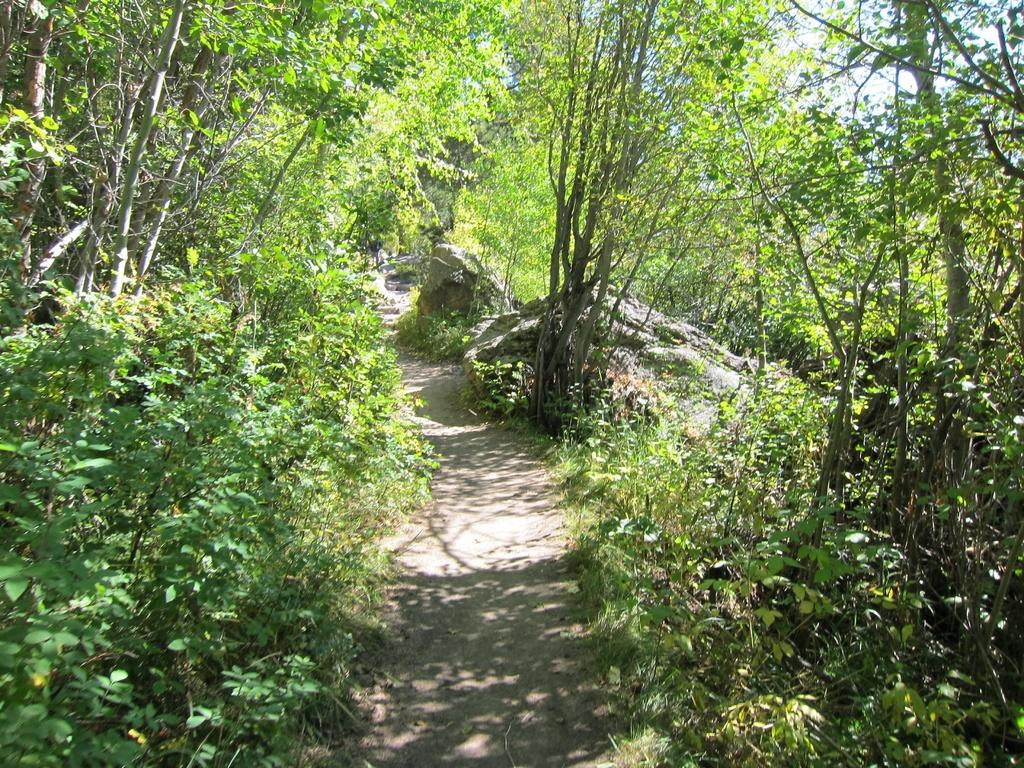What type of environment might the image be taken in? The image might be taken in a forest, as there are trees visible on both sides. Can you describe the left side of the image? A: There are trees on the left side of the image. Can you describe the right side of the image? There are trees on the right side of the image. What can be seen in the center of the image? There is a path in the center of the image. What other elements can be seen in the middle of the image? There are plants, rocks, and trees in the middle of the image. How many eyes can be seen on the trees in the image? There are no eyes visible on the trees in the image, as trees do not have eyes. 